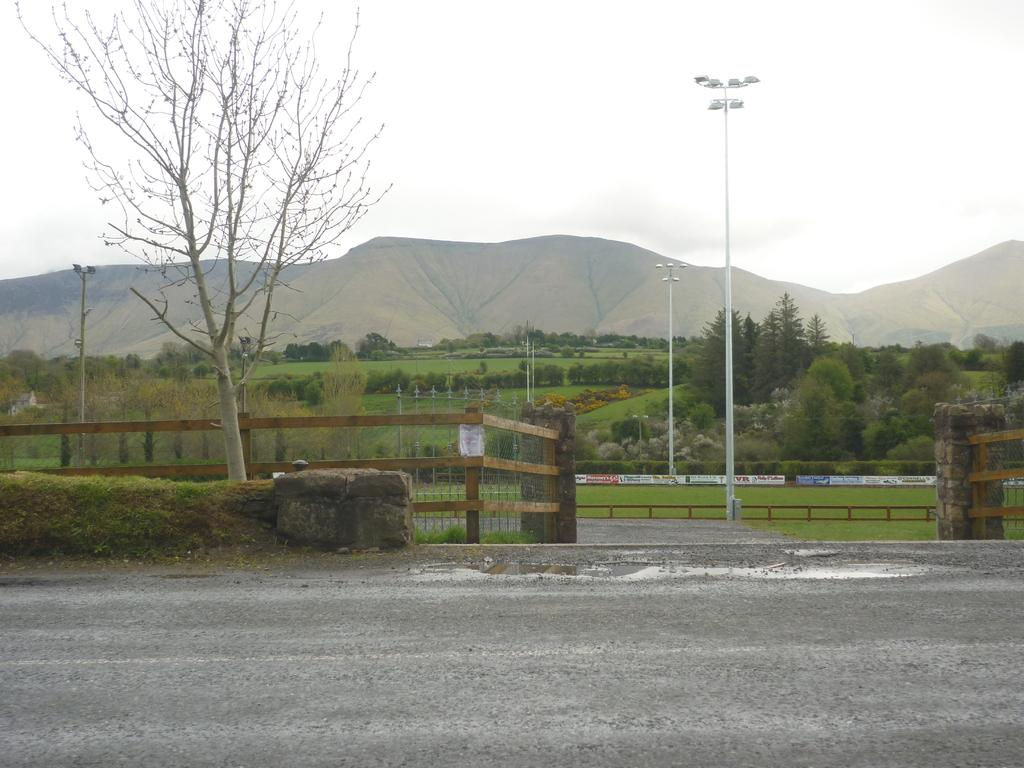What is located at the bottom of the image? There is a road at the bottom of the image. What can be seen in the image besides the road? There is a fence, trees, poles, mountains, and a sky in the image. What type of natural feature is visible in the image? There are trees and mountains in the image. What is visible at the top of the image? There is a sky at the top of the image. Where is the shoe located in the image? There is no shoe present in the image. What type of crowd can be seen gathering around the mountains in the image? There is no crowd present in the image; it only features a road, fence, trees, poles, mountains, and a sky. 